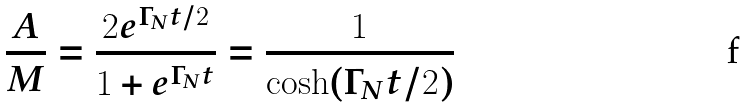Convert formula to latex. <formula><loc_0><loc_0><loc_500><loc_500>\frac { A } { M } = \frac { 2 e ^ { \Gamma _ { N } t / 2 } } { 1 + e ^ { \Gamma _ { N } t } } = \frac { 1 } { \cosh ( \Gamma _ { N } t / 2 ) }</formula> 